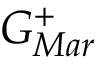<formula> <loc_0><loc_0><loc_500><loc_500>G _ { M a r } ^ { + }</formula> 